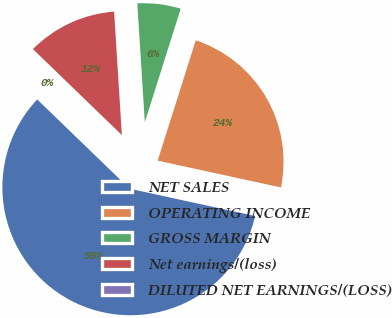Convert chart to OTSL. <chart><loc_0><loc_0><loc_500><loc_500><pie_chart><fcel>NET SALES<fcel>OPERATING INCOME<fcel>GROSS MARGIN<fcel>Net earnings/(loss)<fcel>DILUTED NET EARNINGS/(LOSS)<nl><fcel>58.82%<fcel>23.53%<fcel>5.88%<fcel>11.77%<fcel>0.0%<nl></chart> 